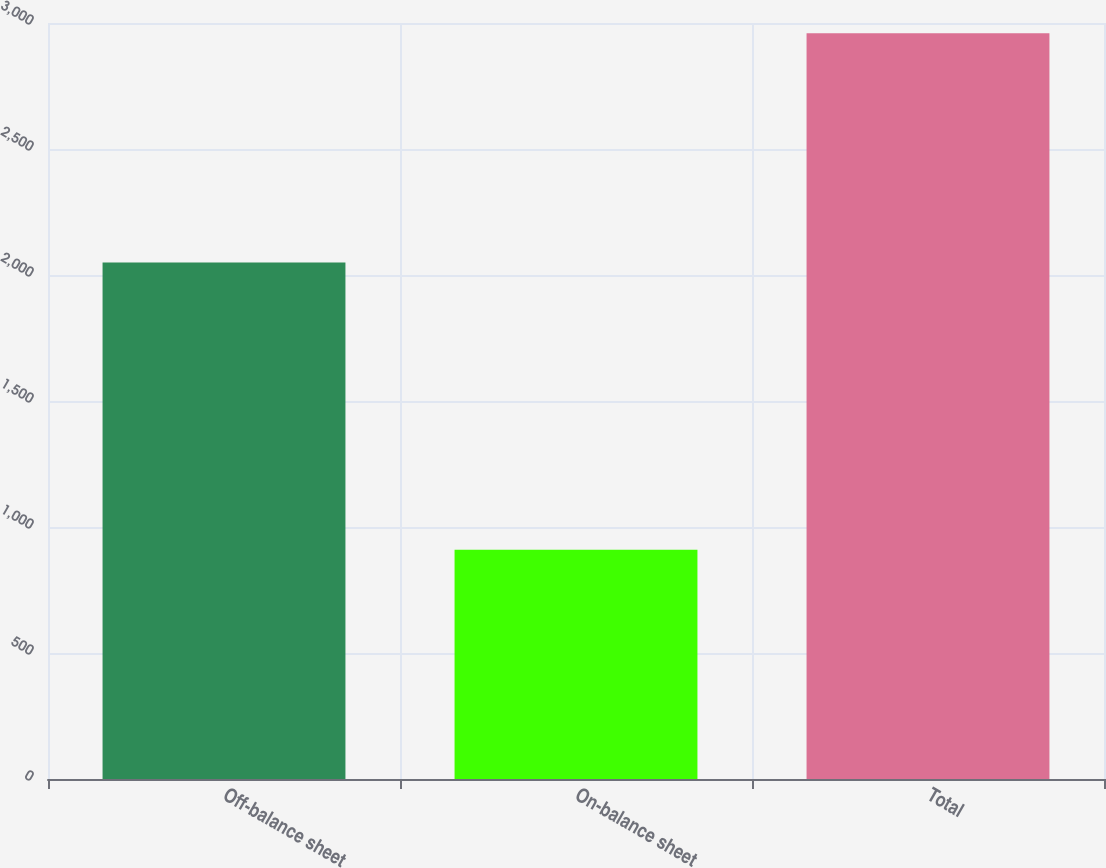Convert chart. <chart><loc_0><loc_0><loc_500><loc_500><bar_chart><fcel>Off-balance sheet<fcel>On-balance sheet<fcel>Total<nl><fcel>2050<fcel>909.5<fcel>2959.5<nl></chart> 